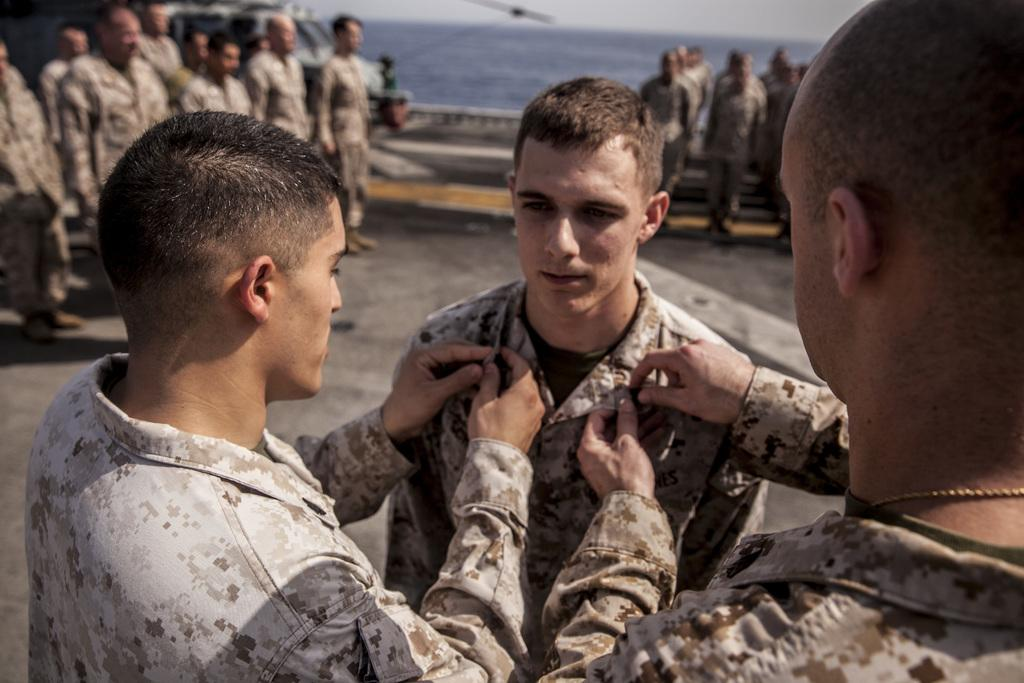How many people are in the image? There is a group of people in the image. Where are the people located? The people are standing on a ship. What else can be seen on the ship? There is a helicopter on the ship. What is the ship's location? The ship is in the water. What suggestion does the helicopter make to the group of people in the image? There is no indication in the image that the helicopter is making any suggestions to the group of people. 